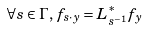<formula> <loc_0><loc_0><loc_500><loc_500>\forall s \in \Gamma , \, f _ { s \cdot y } = L _ { s ^ { - 1 } } ^ { * } f _ { y }</formula> 